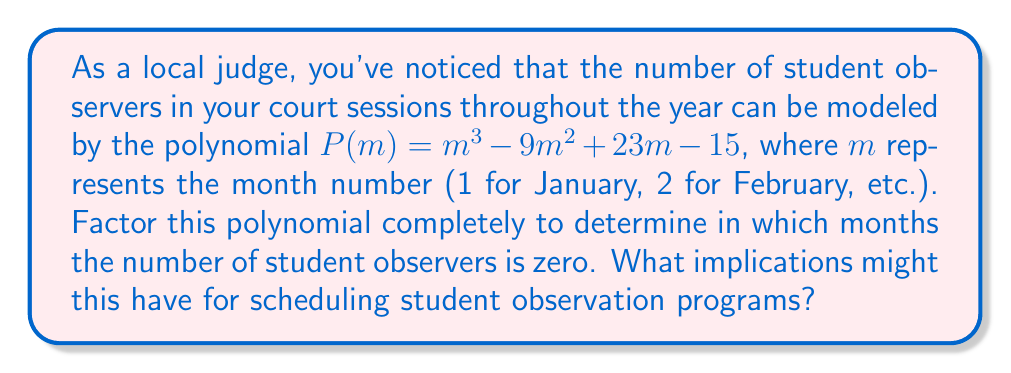Solve this math problem. To solve this problem, we need to factor the polynomial $P(m) = m^3 - 9m^2 + 23m - 15$ completely.

Step 1: Check for a common factor
There is no common factor for all terms, so we proceed to the next step.

Step 2: Try to factor by grouping
This polynomial doesn't easily factor by grouping, so we move to the next step.

Step 3: Use the rational root theorem
The possible rational roots are the factors of the constant term: ±1, ±3, ±5, ±15

Testing these values:
$P(1) = 1 - 9 + 23 - 15 = 0$
$P(3) = 27 - 81 + 69 - 15 = 0$
$P(5) = 125 - 225 + 115 - 15 = 0$

We've found all three roots: 1, 3, and 5.

Step 4: Factor the polynomial
Since we've found all roots, we can factor the polynomial as:

$$P(m) = (m - 1)(m - 3)(m - 5)$$

This means the number of student observers is zero in months 1 (January), 3 (March), and 5 (May).

Implications for scheduling:
1. These months might not be ideal for scheduling student observation programs.
2. The judge might want to focus on other months for student engagement activities.
3. It could be an opportunity to investigate why student participation drops to zero in these months and address any underlying issues.
Answer: The factored polynomial is $P(m) = (m - 1)(m - 3)(m - 5)$. The number of student observers is zero in January (m = 1), March (m = 3), and May (m = 5). 